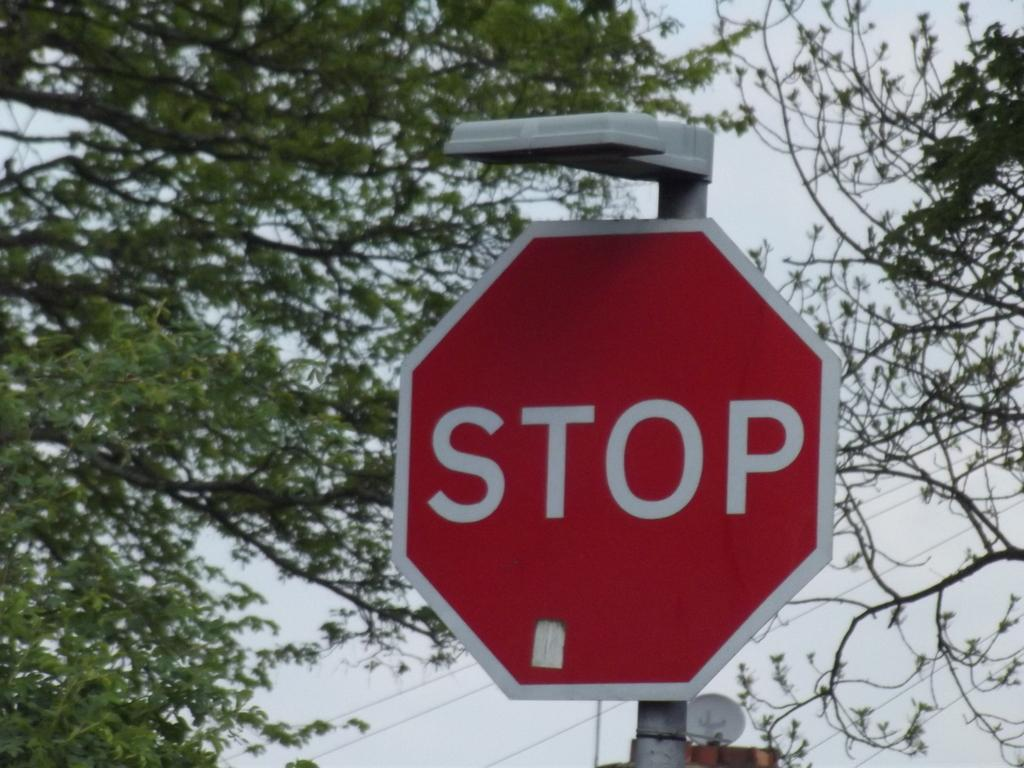Provide a one-sentence caption for the provided image. A red sign that says Stop in a city neighborhood with trees. 